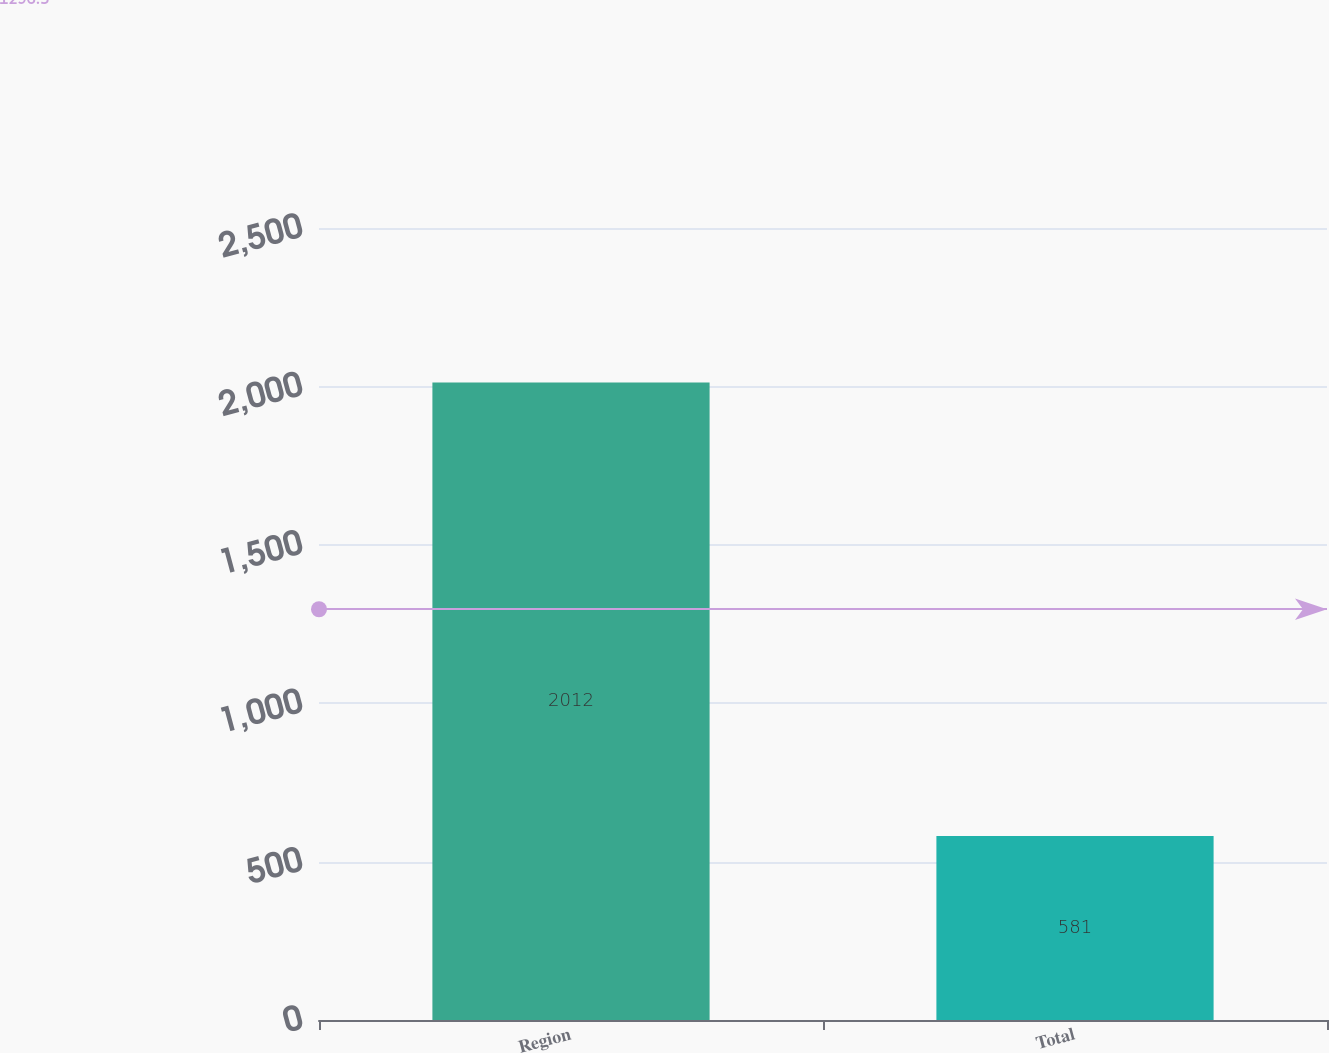Convert chart. <chart><loc_0><loc_0><loc_500><loc_500><bar_chart><fcel>Region<fcel>Total<nl><fcel>2012<fcel>581<nl></chart> 